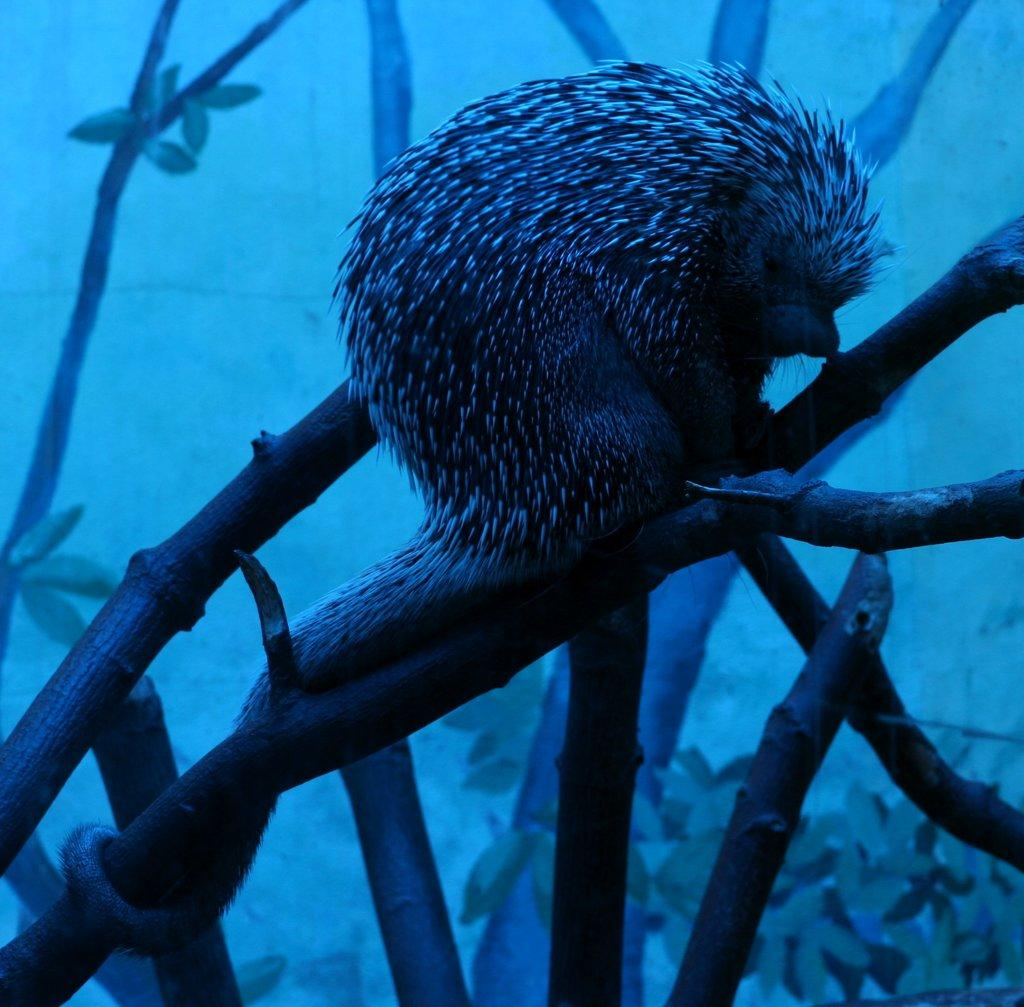What type of animal is in the image? There is a porcupine in the image. Where is the porcupine located in the image? The porcupine is on a branch. In which area of the image is the porcupine situated? The porcupine is in the foreground area of the image. Can you tell me how many volleyballs are visible in the image? There are no volleyballs present in the image. Is the porcupine taking a selfie in the image? There is no indication in the image that the porcupine is taking a selfie. --- 